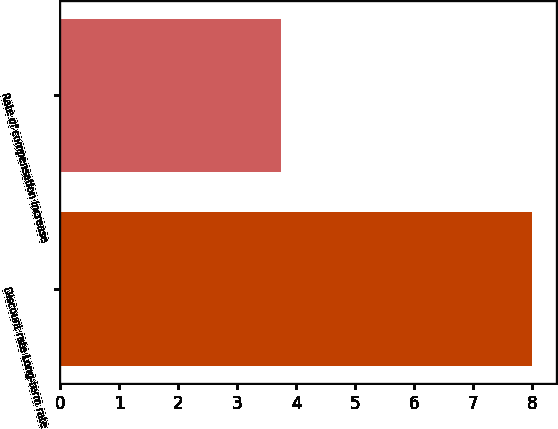Convert chart to OTSL. <chart><loc_0><loc_0><loc_500><loc_500><bar_chart><fcel>Discount rate Long-term rate<fcel>Rate of compensation increase<nl><fcel>8<fcel>3.75<nl></chart> 